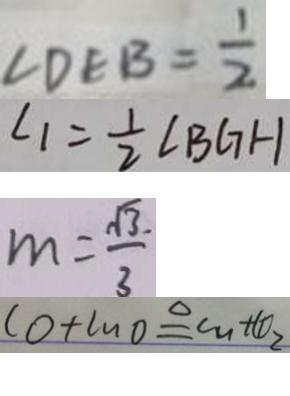<formula> <loc_0><loc_0><loc_500><loc_500>\angle D E B = \frac { 1 } { 2 } 
 \angle 1 = \frac { 1 } { 2 } \angle B G H 
 m = \frac { \sqrt { 3 } } { 3 } 
 C O + C u O \xlongequal { \Delta } C u + C O _ { 2 }</formula> 